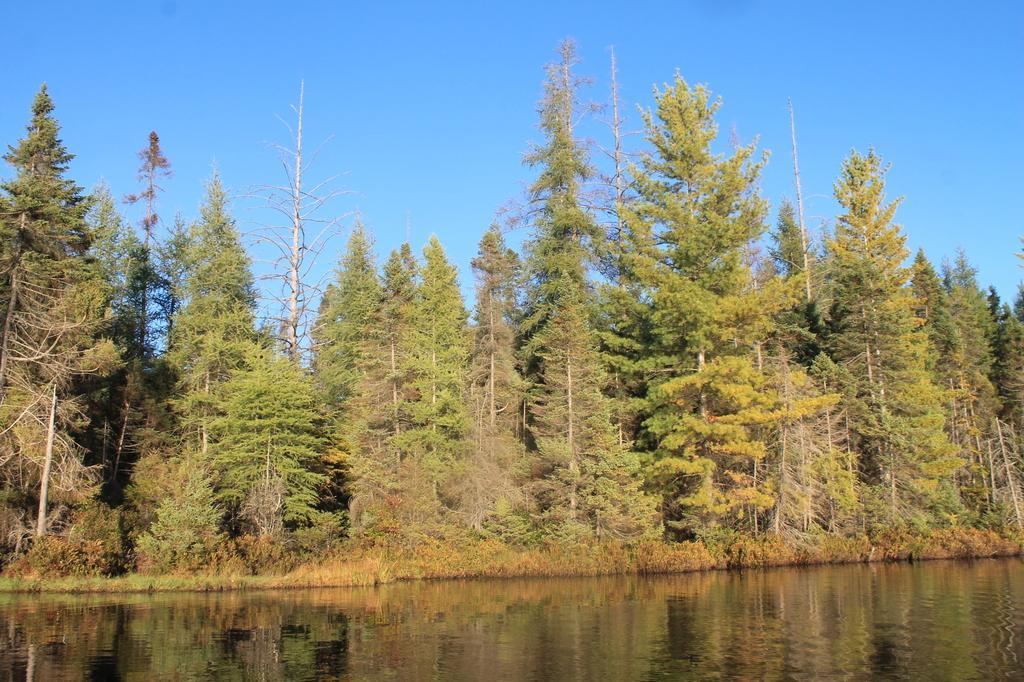Please provide a concise description of this image. In this image, we can see some trees. There is a lake at the bottom of the image. In the background of the image, there is a sky. 